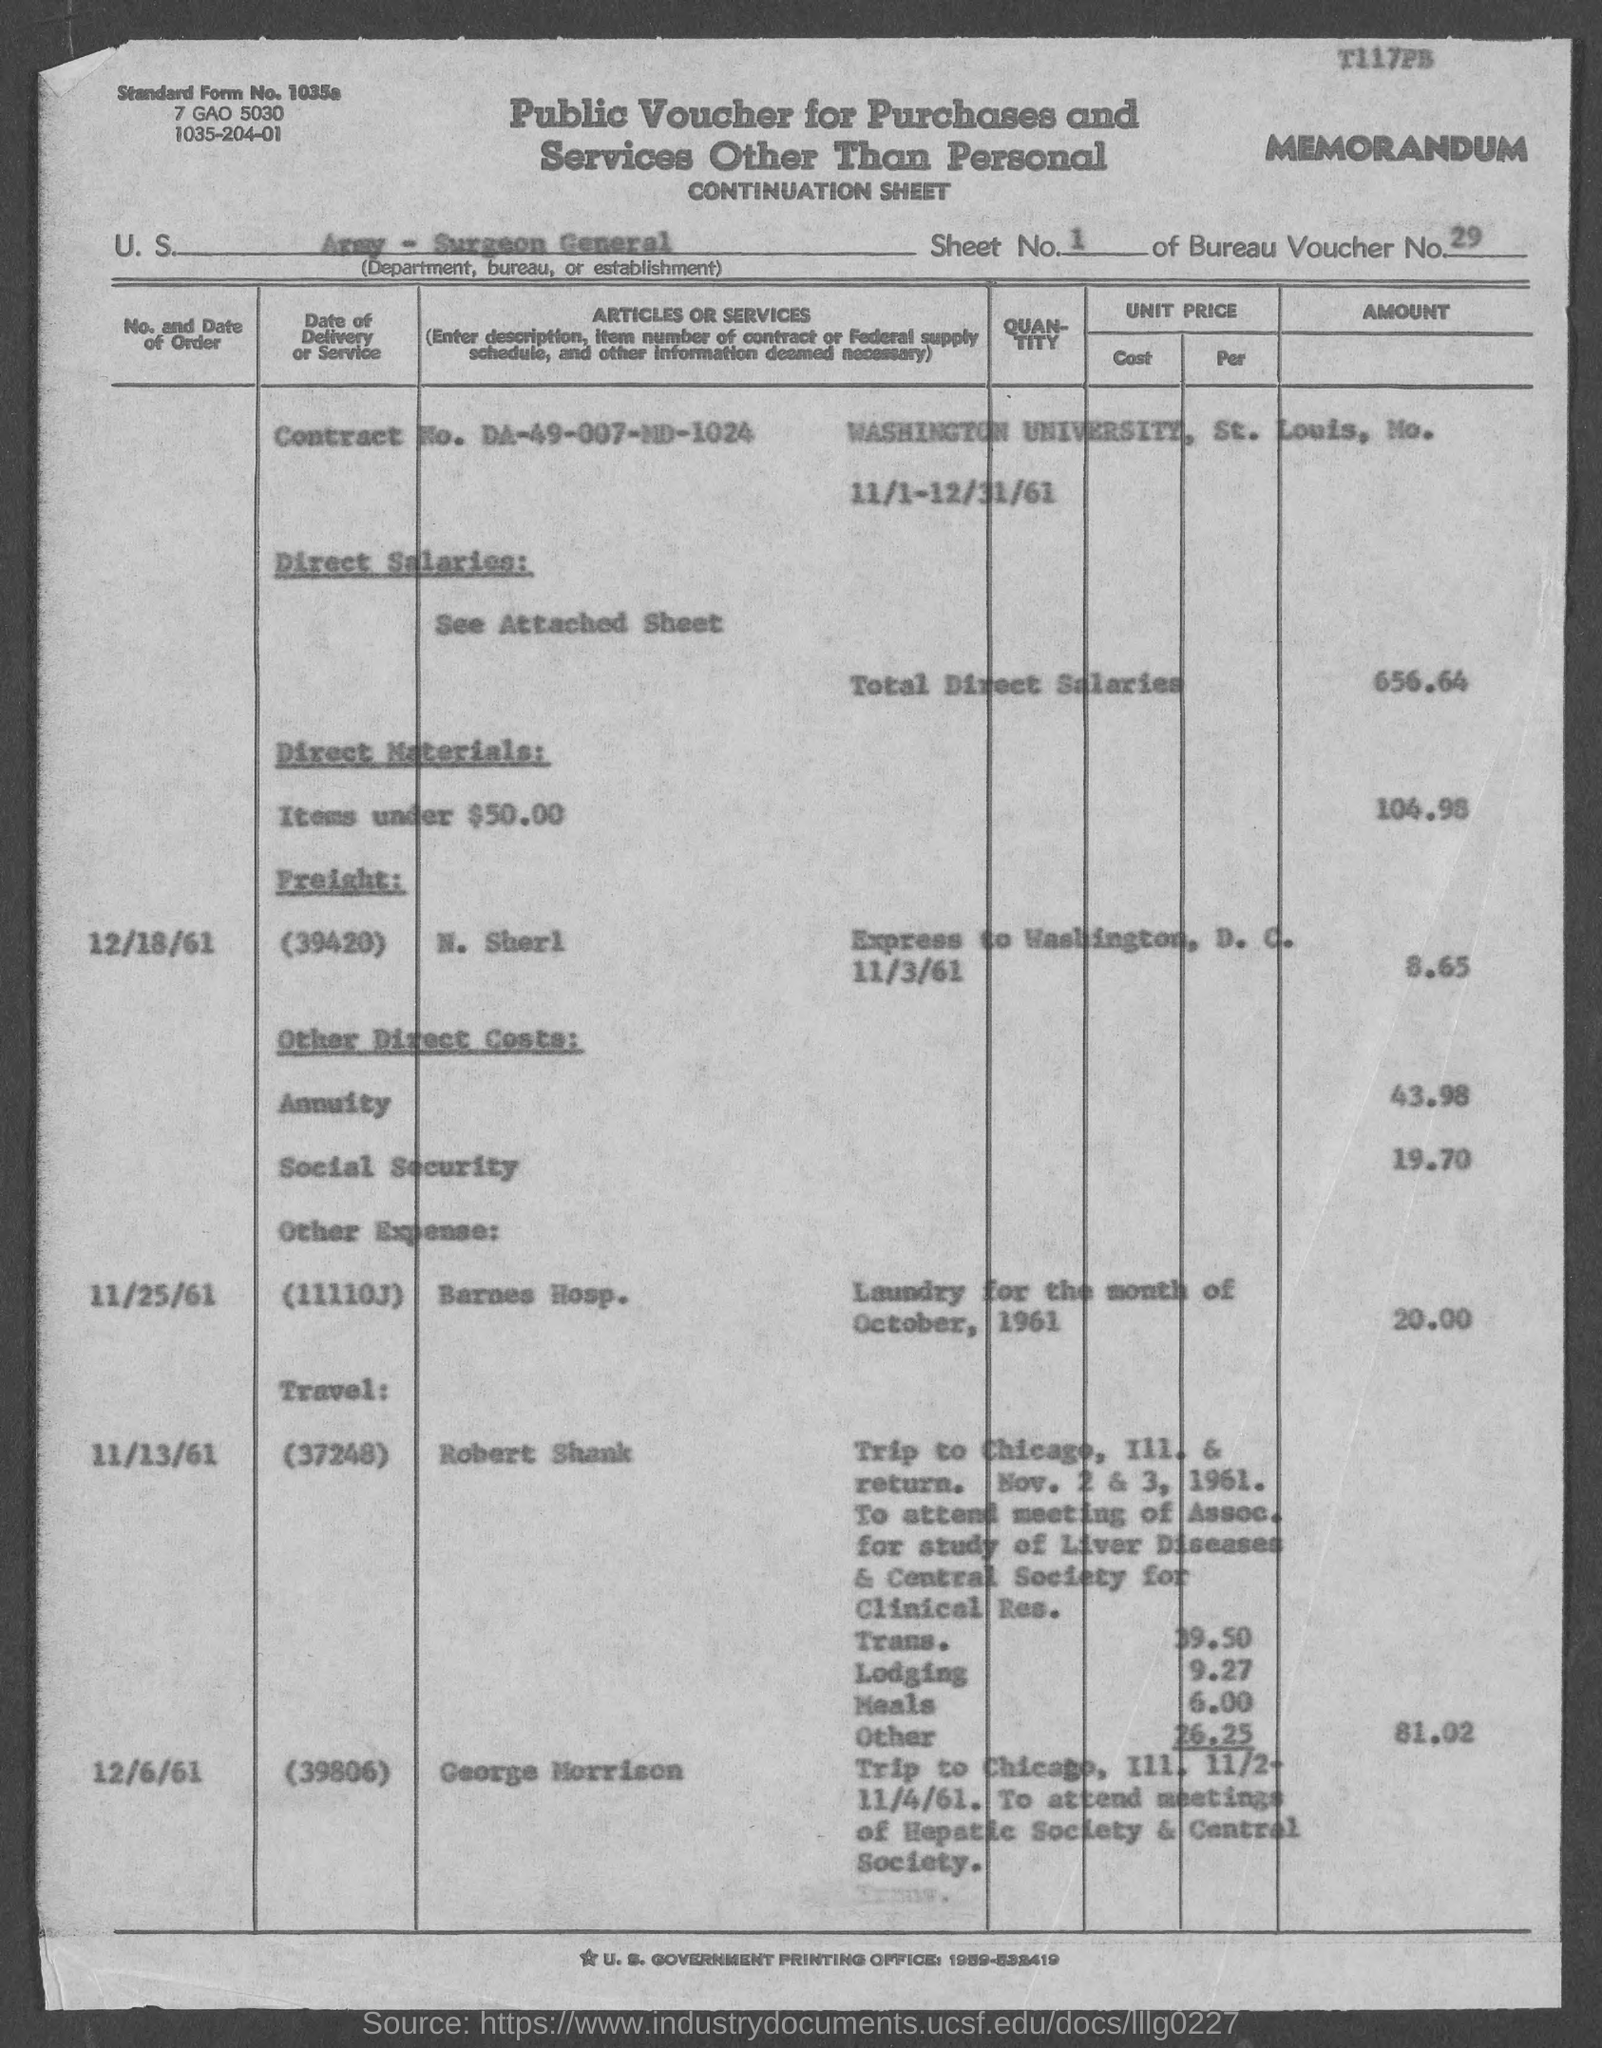What is the sheet no.?
Offer a very short reply. 1. What is the bureau voucher no.?
Your answer should be compact. 29. What is the standard form no.?
Offer a very short reply. 1035a. What is the contract no.?
Make the answer very short. DA-49-007-MD-1024. In which county is washington university at ?
Provide a succinct answer. St. Louis. What is total direct salaries amount ?
Your response must be concise. $656.64. 